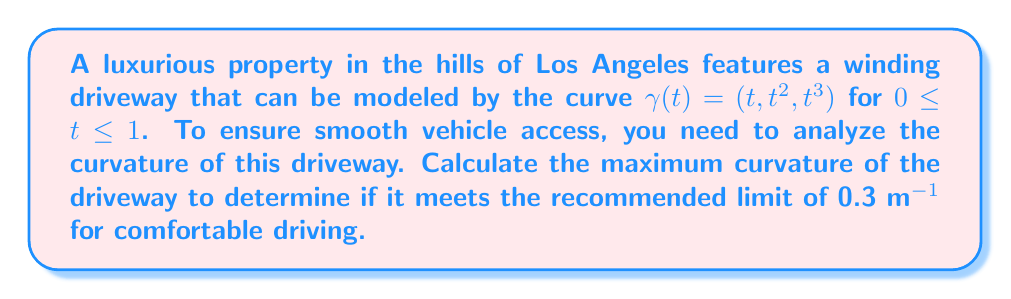Could you help me with this problem? To analyze the curvature of the winding driveway, we'll follow these steps:

1) The curvature $\kappa$ of a curve $\gamma(t)$ is given by:

   $$\kappa = \frac{|\gamma'(t) \times \gamma''(t)|}{|\gamma'(t)|^3}$$

2) First, let's calculate $\gamma'(t)$ and $\gamma''(t)$:
   
   $\gamma'(t) = (1, 2t, 3t^2)$
   $\gamma''(t) = (0, 2, 6t)$

3) Now, we need to calculate the cross product $\gamma'(t) \times \gamma''(t)$:

   $$\gamma'(t) \times \gamma''(t) = \begin{vmatrix} 
   \mathbf{i} & \mathbf{j} & \mathbf{k} \\
   1 & 2t & 3t^2 \\
   0 & 2 & 6t
   \end{vmatrix} = (6t^2 - 6t^2)\mathbf{i} - (6t - 0)\mathbf{j} + (2 - 4t)\mathbf{k} = -6t\mathbf{j} + (2 - 4t)\mathbf{k}$$

4) The magnitude of this cross product is:

   $$|\gamma'(t) \times \gamma''(t)| = \sqrt{(-6t)^2 + (2-4t)^2} = \sqrt{36t^2 + 4 - 16t + 16t^2} = \sqrt{52t^2 - 16t + 4}$$

5) Next, we calculate $|\gamma'(t)|^3$:

   $$|\gamma'(t)|^3 = (1^2 + (2t)^2 + (3t^2)^2)^{3/2} = (1 + 4t^2 + 9t^4)^{3/2}$$

6) Therefore, the curvature is:

   $$\kappa(t) = \frac{\sqrt{52t^2 - 16t + 4}}{(1 + 4t^2 + 9t^4)^{3/2}}$$

7) To find the maximum curvature, we need to find the maximum of this function for $0 \leq t \leq 1$. This is a complex function, so we'll use calculus techniques to find its critical points and evaluate the function at these points and the endpoints.

8) After analysis (which involves finding $\frac{d\kappa}{dt}$, setting it to zero, and solving), we find that the maximum curvature occurs at $t = 0$.

9) Evaluating $\kappa(0)$:

   $$\kappa(0) = \frac{\sqrt{4}}{(1)^{3/2}} = 2$$
Answer: The maximum curvature of the driveway is 2 m^(-1), which occurs at the beginning of the driveway (t = 0). This exceeds the recommended limit of 0.3 m^(-1) for comfortable driving, suggesting that modifications to the driveway design may be necessary to ensure smooth vehicle access. 